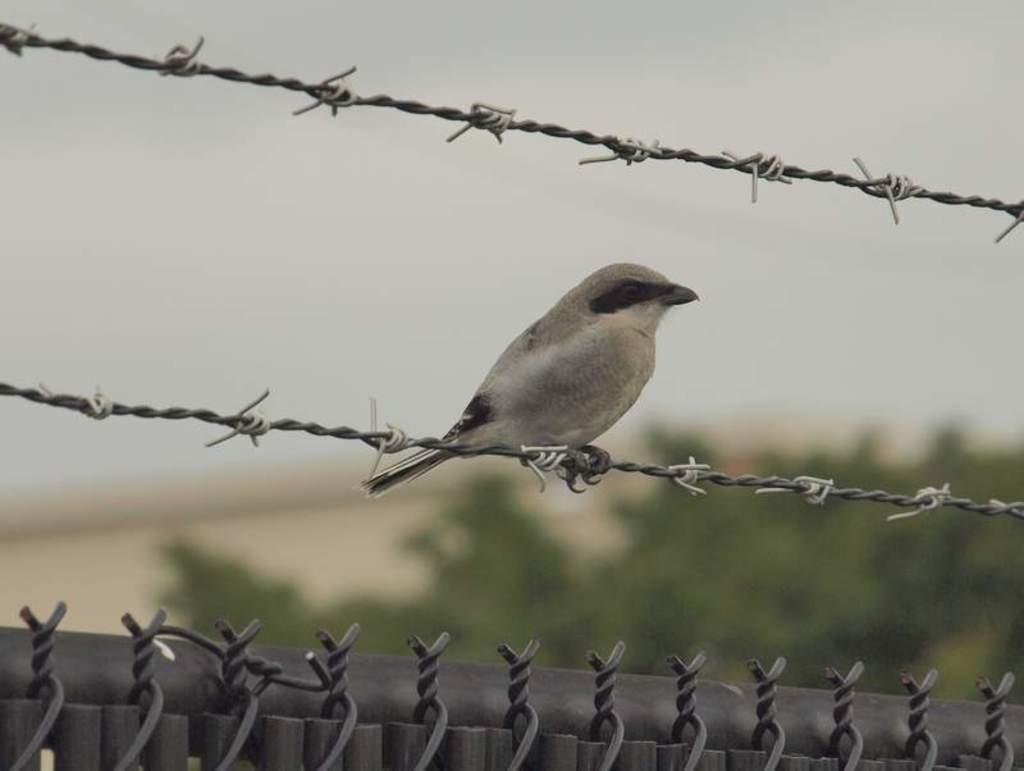Describe this image in one or two sentences. There is a bird sitting on a wire fencing. In the background it is blurred. 